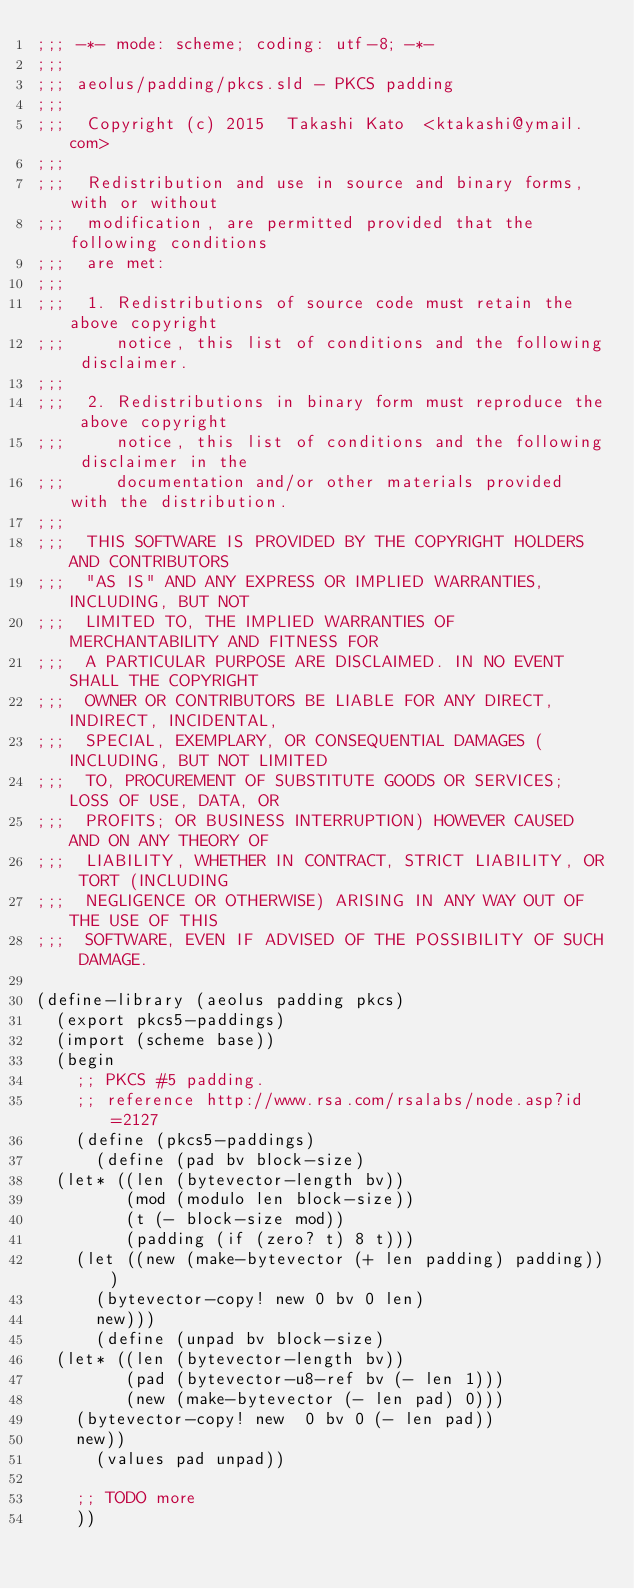<code> <loc_0><loc_0><loc_500><loc_500><_Scheme_>;;; -*- mode: scheme; coding: utf-8; -*-
;;;
;;; aeolus/padding/pkcs.sld - PKCS padding
;;;
;;;  Copyright (c) 2015  Takashi Kato  <ktakashi@ymail.com>
;;;  
;;;  Redistribution and use in source and binary forms, with or without
;;;  modification, are permitted provided that the following conditions
;;;  are met:
;;;  
;;;  1. Redistributions of source code must retain the above copyright
;;;     notice, this list of conditions and the following disclaimer.
;;;  
;;;  2. Redistributions in binary form must reproduce the above copyright
;;;     notice, this list of conditions and the following disclaimer in the
;;;     documentation and/or other materials provided with the distribution.
;;;  
;;;  THIS SOFTWARE IS PROVIDED BY THE COPYRIGHT HOLDERS AND CONTRIBUTORS
;;;  "AS IS" AND ANY EXPRESS OR IMPLIED WARRANTIES, INCLUDING, BUT NOT
;;;  LIMITED TO, THE IMPLIED WARRANTIES OF MERCHANTABILITY AND FITNESS FOR
;;;  A PARTICULAR PURPOSE ARE DISCLAIMED. IN NO EVENT SHALL THE COPYRIGHT
;;;  OWNER OR CONTRIBUTORS BE LIABLE FOR ANY DIRECT, INDIRECT, INCIDENTAL,
;;;  SPECIAL, EXEMPLARY, OR CONSEQUENTIAL DAMAGES (INCLUDING, BUT NOT LIMITED
;;;  TO, PROCUREMENT OF SUBSTITUTE GOODS OR SERVICES; LOSS OF USE, DATA, OR
;;;  PROFITS; OR BUSINESS INTERRUPTION) HOWEVER CAUSED AND ON ANY THEORY OF
;;;  LIABILITY, WHETHER IN CONTRACT, STRICT LIABILITY, OR TORT (INCLUDING
;;;  NEGLIGENCE OR OTHERWISE) ARISING IN ANY WAY OUT OF THE USE OF THIS
;;;  SOFTWARE, EVEN IF ADVISED OF THE POSSIBILITY OF SUCH DAMAGE.

(define-library (aeolus padding pkcs)
  (export pkcs5-paddings)
  (import (scheme base))
  (begin
    ;; PKCS #5 padding.
    ;; reference http://www.rsa.com/rsalabs/node.asp?id=2127
    (define (pkcs5-paddings)
      (define (pad bv block-size)
	(let* ((len (bytevector-length bv))
	       (mod (modulo len block-size))
	       (t (- block-size mod))
	       (padding (if (zero? t) 8 t)))
	  (let ((new (make-bytevector (+ len padding) padding)))
	    (bytevector-copy! new 0 bv 0 len)
	    new)))
      (define (unpad bv block-size)
	(let* ((len (bytevector-length bv))
	       (pad (bytevector-u8-ref bv (- len 1)))
	       (new (make-bytevector (- len pad) 0)))
	  (bytevector-copy! new  0 bv 0 (- len pad))
	  new))
      (values pad unpad))

    ;; TODO more
    ))
</code> 